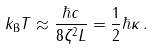<formula> <loc_0><loc_0><loc_500><loc_500>k _ { \text {B} } T \approx \frac { \hbar { c } } { 8 \zeta ^ { 2 } L } = \frac { 1 } { 2 } \hbar { \kappa } \, .</formula> 